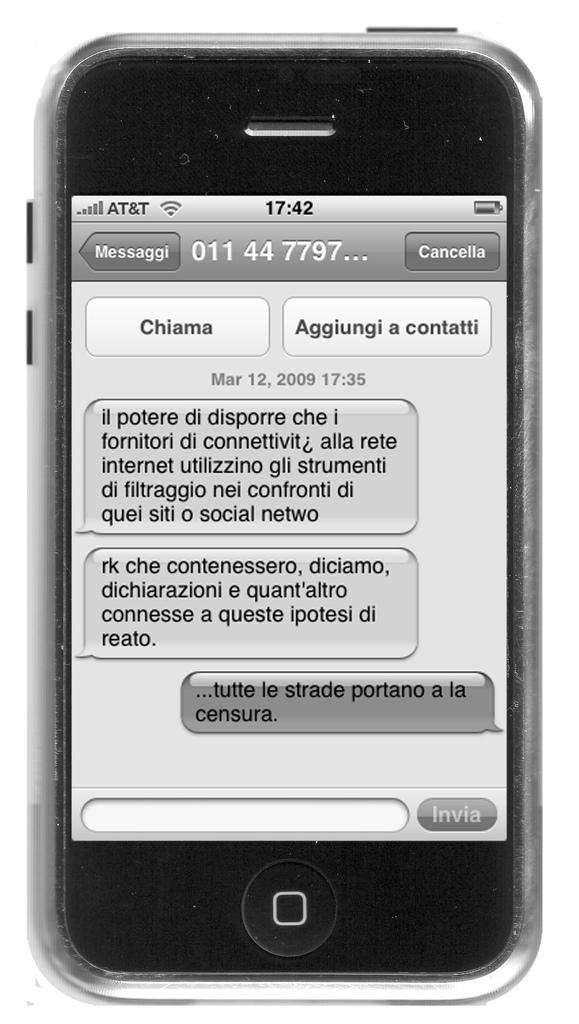Provide a one-sentence caption for the provided image. An iPhone screen displaying a conversation shows the time of 17:42. 